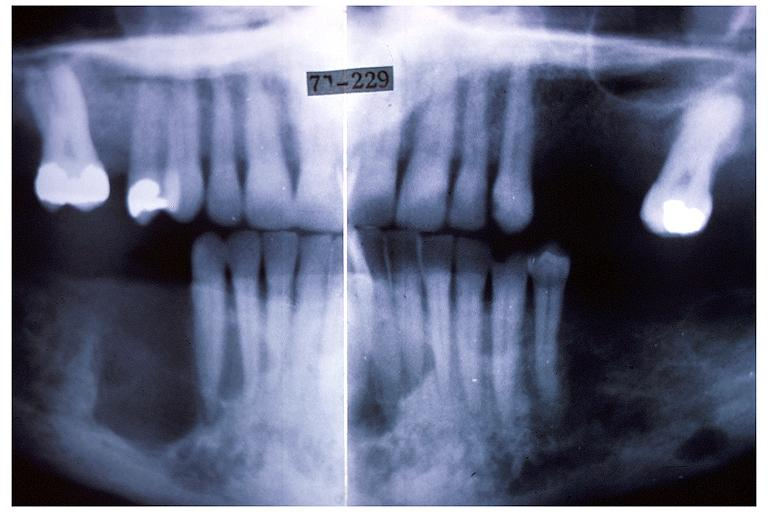what does this image show?
Answer the question using a single word or phrase. Hyperparathyroidism brown tumor 